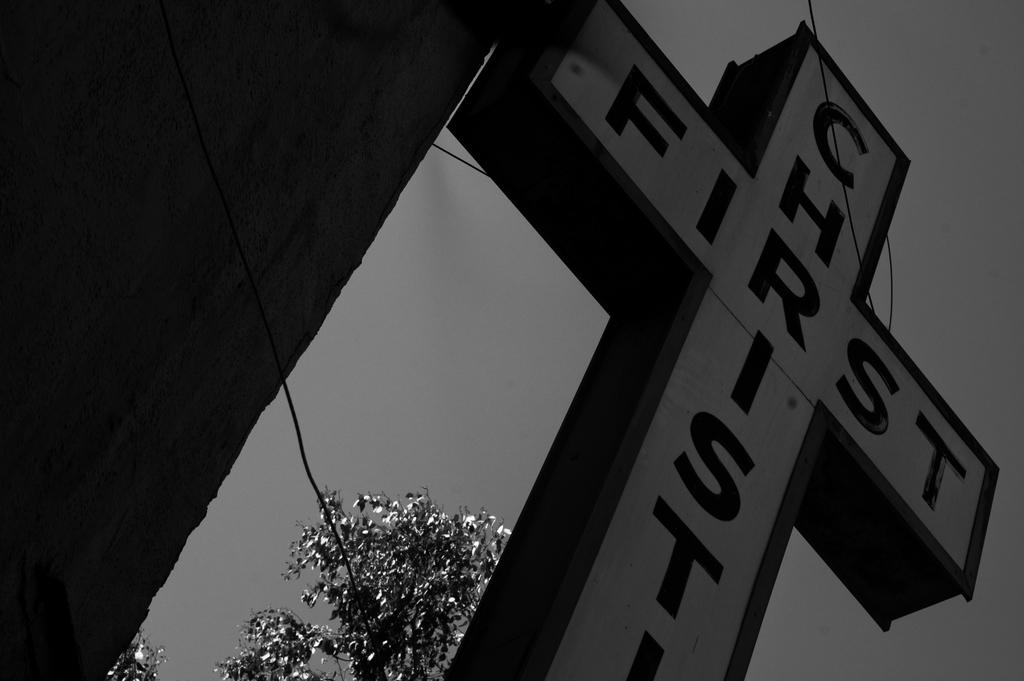What is the main object in the image? There is a display board in the image. What can be seen behind the display board? There is a tree visible behind the display board. How many brothers are standing next to the display board in the image? There is no mention of any brothers in the image, as it only features a display board and a tree in the background. 